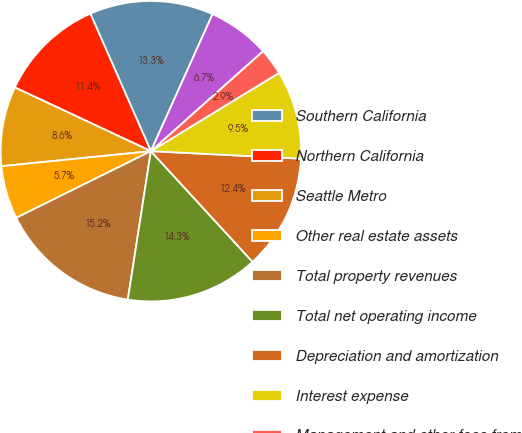Convert chart. <chart><loc_0><loc_0><loc_500><loc_500><pie_chart><fcel>Southern California<fcel>Northern California<fcel>Seattle Metro<fcel>Other real estate assets<fcel>Total property revenues<fcel>Total net operating income<fcel>Depreciation and amortization<fcel>Interest expense<fcel>Management and other fees from<fcel>General and administrative<nl><fcel>13.33%<fcel>11.43%<fcel>8.57%<fcel>5.72%<fcel>15.23%<fcel>14.28%<fcel>12.38%<fcel>9.52%<fcel>2.87%<fcel>6.67%<nl></chart> 